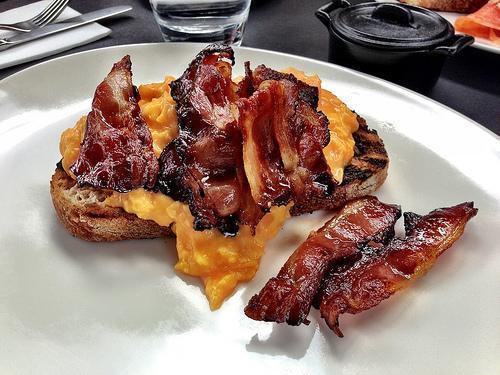How many fish are jumping on the plate?
Give a very brief answer. 0. 